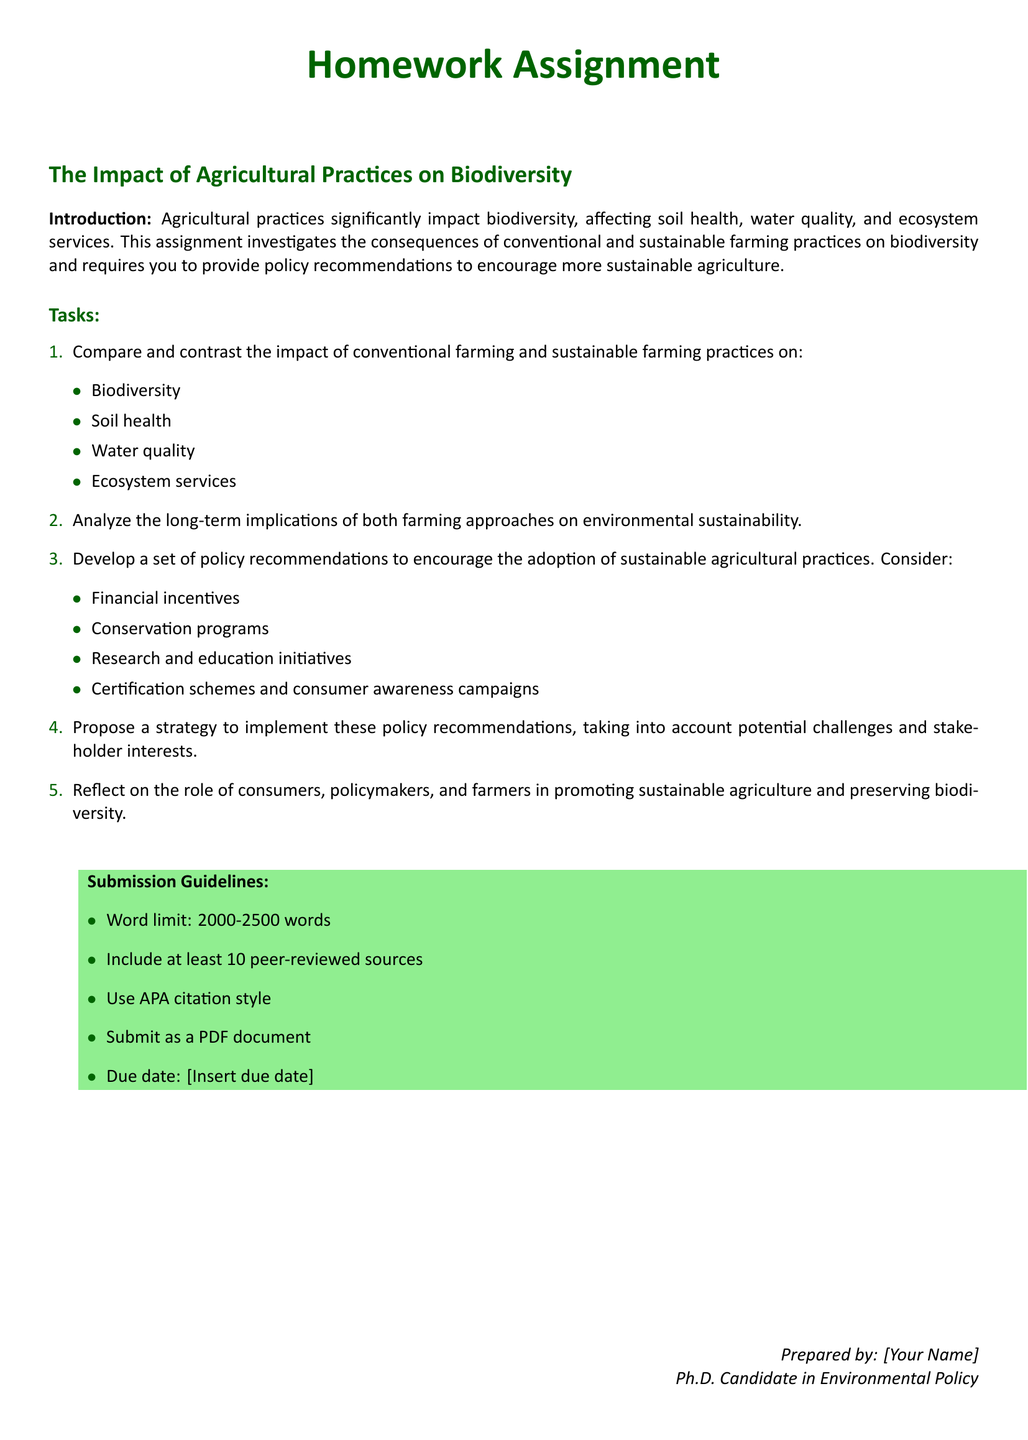What is the title of the homework assignment? The title of the homework assignment is located at the beginning of the document, stating the focus of the assignment.
Answer: The Impact of Agricultural Practices on Biodiversity What are the main topics students must compare? The document outlines specific topics that need to be compared in the first task of the assignment.
Answer: Biodiversity, Soil health, Water quality, Ecosystem services What is the word limit for the assignment? The word limit is specified in the submission guidelines section, providing a range that students must follow.
Answer: 2000-2500 words How many peer-reviewed sources must be included? The requirement for the number of peer-reviewed sources is detailed in the submission guidelines.
Answer: 10 Name one type of policy recommendation students should consider. The document lists various policy recommendations, and one of them can be directly picked from the relevant task.
Answer: Financial incentives What is the due date for this assignment? The due date is mentioned in the submission guidelines but is indicated for the instructor to fill in.
Answer: [Insert due date] What role do consumers play in promoting sustainable agriculture? This is outlined in the final task, which reflects on different stakeholders' roles.
Answer: Consumers What color scheme is used for headings in the document? The headings are styled using a specific color that enhances visibility and aesthetics in the document.
Answer: Dark green 